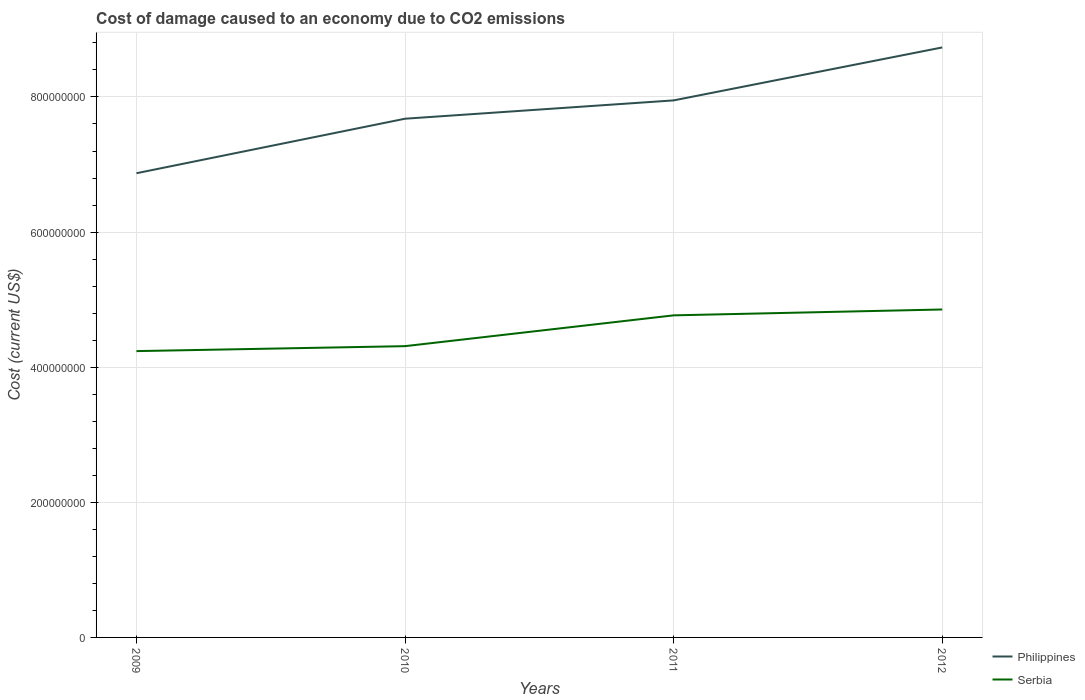Is the number of lines equal to the number of legend labels?
Give a very brief answer. Yes. Across all years, what is the maximum cost of damage caused due to CO2 emissisons in Serbia?
Provide a succinct answer. 4.24e+08. In which year was the cost of damage caused due to CO2 emissisons in Serbia maximum?
Your answer should be compact. 2009. What is the total cost of damage caused due to CO2 emissisons in Philippines in the graph?
Make the answer very short. -1.08e+08. What is the difference between the highest and the second highest cost of damage caused due to CO2 emissisons in Serbia?
Offer a very short reply. 6.16e+07. What is the difference between the highest and the lowest cost of damage caused due to CO2 emissisons in Philippines?
Give a very brief answer. 2. Is the cost of damage caused due to CO2 emissisons in Philippines strictly greater than the cost of damage caused due to CO2 emissisons in Serbia over the years?
Make the answer very short. No. How many years are there in the graph?
Provide a succinct answer. 4. What is the difference between two consecutive major ticks on the Y-axis?
Your response must be concise. 2.00e+08. Are the values on the major ticks of Y-axis written in scientific E-notation?
Provide a short and direct response. No. Does the graph contain any zero values?
Make the answer very short. No. How many legend labels are there?
Make the answer very short. 2. What is the title of the graph?
Provide a short and direct response. Cost of damage caused to an economy due to CO2 emissions. Does "Timor-Leste" appear as one of the legend labels in the graph?
Keep it short and to the point. No. What is the label or title of the Y-axis?
Ensure brevity in your answer.  Cost (current US$). What is the Cost (current US$) in Philippines in 2009?
Provide a succinct answer. 6.87e+08. What is the Cost (current US$) in Serbia in 2009?
Your answer should be compact. 4.24e+08. What is the Cost (current US$) of Philippines in 2010?
Make the answer very short. 7.68e+08. What is the Cost (current US$) in Serbia in 2010?
Your answer should be compact. 4.31e+08. What is the Cost (current US$) in Philippines in 2011?
Your answer should be very brief. 7.95e+08. What is the Cost (current US$) of Serbia in 2011?
Make the answer very short. 4.77e+08. What is the Cost (current US$) of Philippines in 2012?
Your answer should be compact. 8.73e+08. What is the Cost (current US$) in Serbia in 2012?
Make the answer very short. 4.85e+08. Across all years, what is the maximum Cost (current US$) of Philippines?
Provide a short and direct response. 8.73e+08. Across all years, what is the maximum Cost (current US$) of Serbia?
Offer a terse response. 4.85e+08. Across all years, what is the minimum Cost (current US$) in Philippines?
Provide a succinct answer. 6.87e+08. Across all years, what is the minimum Cost (current US$) in Serbia?
Make the answer very short. 4.24e+08. What is the total Cost (current US$) of Philippines in the graph?
Provide a short and direct response. 3.12e+09. What is the total Cost (current US$) in Serbia in the graph?
Your answer should be very brief. 1.82e+09. What is the difference between the Cost (current US$) in Philippines in 2009 and that in 2010?
Give a very brief answer. -8.07e+07. What is the difference between the Cost (current US$) of Serbia in 2009 and that in 2010?
Make the answer very short. -7.34e+06. What is the difference between the Cost (current US$) in Philippines in 2009 and that in 2011?
Offer a very short reply. -1.08e+08. What is the difference between the Cost (current US$) of Serbia in 2009 and that in 2011?
Ensure brevity in your answer.  -5.29e+07. What is the difference between the Cost (current US$) in Philippines in 2009 and that in 2012?
Provide a short and direct response. -1.86e+08. What is the difference between the Cost (current US$) of Serbia in 2009 and that in 2012?
Offer a terse response. -6.16e+07. What is the difference between the Cost (current US$) in Philippines in 2010 and that in 2011?
Ensure brevity in your answer.  -2.71e+07. What is the difference between the Cost (current US$) of Serbia in 2010 and that in 2011?
Ensure brevity in your answer.  -4.56e+07. What is the difference between the Cost (current US$) of Philippines in 2010 and that in 2012?
Give a very brief answer. -1.06e+08. What is the difference between the Cost (current US$) in Serbia in 2010 and that in 2012?
Ensure brevity in your answer.  -5.43e+07. What is the difference between the Cost (current US$) in Philippines in 2011 and that in 2012?
Ensure brevity in your answer.  -7.84e+07. What is the difference between the Cost (current US$) in Serbia in 2011 and that in 2012?
Provide a succinct answer. -8.68e+06. What is the difference between the Cost (current US$) of Philippines in 2009 and the Cost (current US$) of Serbia in 2010?
Ensure brevity in your answer.  2.56e+08. What is the difference between the Cost (current US$) in Philippines in 2009 and the Cost (current US$) in Serbia in 2011?
Your answer should be very brief. 2.10e+08. What is the difference between the Cost (current US$) of Philippines in 2009 and the Cost (current US$) of Serbia in 2012?
Ensure brevity in your answer.  2.02e+08. What is the difference between the Cost (current US$) of Philippines in 2010 and the Cost (current US$) of Serbia in 2011?
Your answer should be very brief. 2.91e+08. What is the difference between the Cost (current US$) of Philippines in 2010 and the Cost (current US$) of Serbia in 2012?
Provide a short and direct response. 2.82e+08. What is the difference between the Cost (current US$) in Philippines in 2011 and the Cost (current US$) in Serbia in 2012?
Provide a succinct answer. 3.10e+08. What is the average Cost (current US$) in Philippines per year?
Keep it short and to the point. 7.81e+08. What is the average Cost (current US$) in Serbia per year?
Give a very brief answer. 4.54e+08. In the year 2009, what is the difference between the Cost (current US$) in Philippines and Cost (current US$) in Serbia?
Ensure brevity in your answer.  2.63e+08. In the year 2010, what is the difference between the Cost (current US$) of Philippines and Cost (current US$) of Serbia?
Your response must be concise. 3.37e+08. In the year 2011, what is the difference between the Cost (current US$) of Philippines and Cost (current US$) of Serbia?
Provide a short and direct response. 3.18e+08. In the year 2012, what is the difference between the Cost (current US$) of Philippines and Cost (current US$) of Serbia?
Keep it short and to the point. 3.88e+08. What is the ratio of the Cost (current US$) of Philippines in 2009 to that in 2010?
Keep it short and to the point. 0.89. What is the ratio of the Cost (current US$) of Serbia in 2009 to that in 2010?
Make the answer very short. 0.98. What is the ratio of the Cost (current US$) of Philippines in 2009 to that in 2011?
Offer a terse response. 0.86. What is the ratio of the Cost (current US$) in Serbia in 2009 to that in 2011?
Ensure brevity in your answer.  0.89. What is the ratio of the Cost (current US$) of Philippines in 2009 to that in 2012?
Your response must be concise. 0.79. What is the ratio of the Cost (current US$) of Serbia in 2009 to that in 2012?
Ensure brevity in your answer.  0.87. What is the ratio of the Cost (current US$) in Philippines in 2010 to that in 2011?
Your answer should be very brief. 0.97. What is the ratio of the Cost (current US$) of Serbia in 2010 to that in 2011?
Provide a short and direct response. 0.9. What is the ratio of the Cost (current US$) of Philippines in 2010 to that in 2012?
Your answer should be very brief. 0.88. What is the ratio of the Cost (current US$) in Serbia in 2010 to that in 2012?
Make the answer very short. 0.89. What is the ratio of the Cost (current US$) of Philippines in 2011 to that in 2012?
Offer a terse response. 0.91. What is the ratio of the Cost (current US$) of Serbia in 2011 to that in 2012?
Your response must be concise. 0.98. What is the difference between the highest and the second highest Cost (current US$) of Philippines?
Provide a short and direct response. 7.84e+07. What is the difference between the highest and the second highest Cost (current US$) in Serbia?
Your answer should be compact. 8.68e+06. What is the difference between the highest and the lowest Cost (current US$) of Philippines?
Provide a short and direct response. 1.86e+08. What is the difference between the highest and the lowest Cost (current US$) of Serbia?
Give a very brief answer. 6.16e+07. 